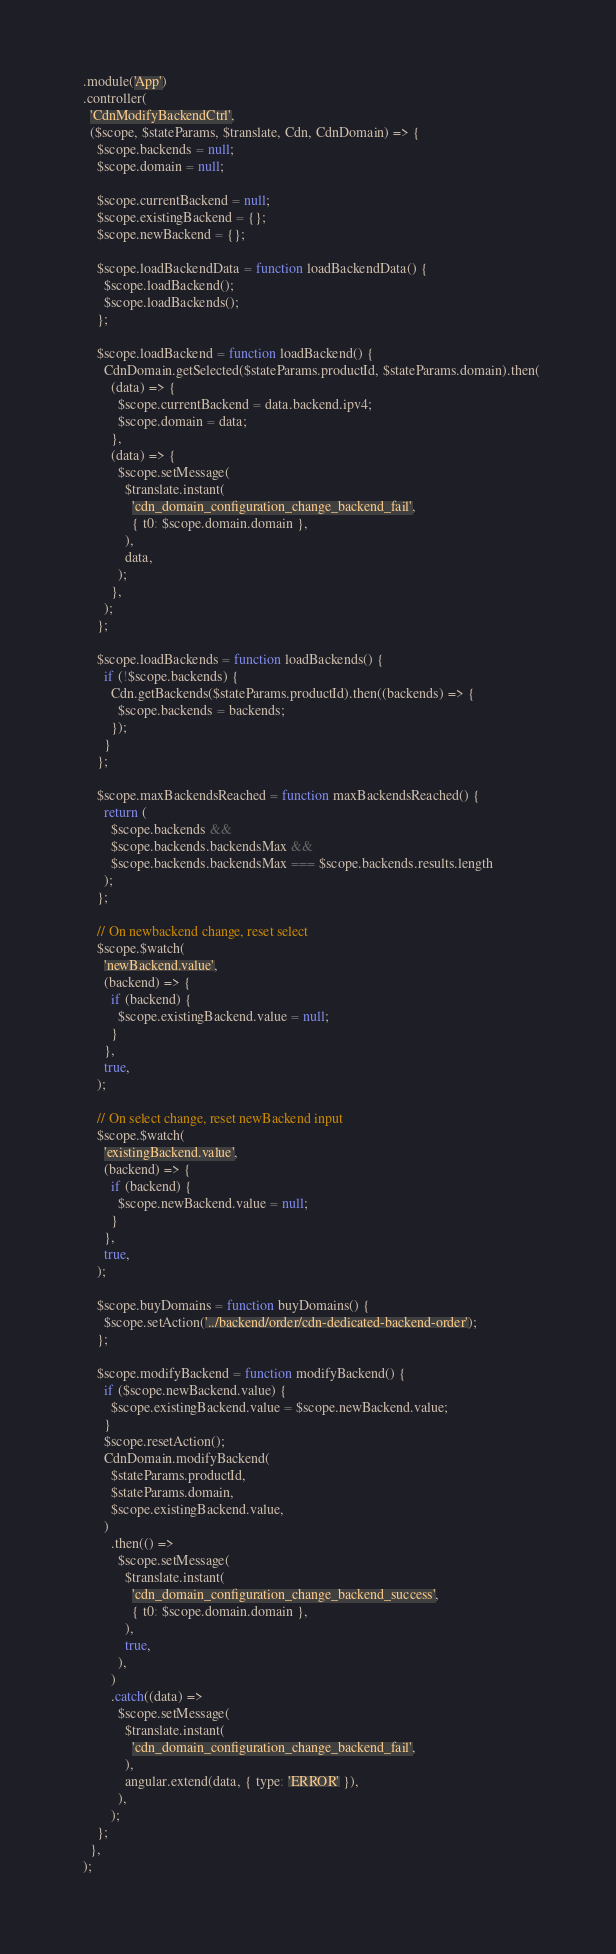<code> <loc_0><loc_0><loc_500><loc_500><_JavaScript_>  .module('App')
  .controller(
    'CdnModifyBackendCtrl',
    ($scope, $stateParams, $translate, Cdn, CdnDomain) => {
      $scope.backends = null;
      $scope.domain = null;

      $scope.currentBackend = null;
      $scope.existingBackend = {};
      $scope.newBackend = {};

      $scope.loadBackendData = function loadBackendData() {
        $scope.loadBackend();
        $scope.loadBackends();
      };

      $scope.loadBackend = function loadBackend() {
        CdnDomain.getSelected($stateParams.productId, $stateParams.domain).then(
          (data) => {
            $scope.currentBackend = data.backend.ipv4;
            $scope.domain = data;
          },
          (data) => {
            $scope.setMessage(
              $translate.instant(
                'cdn_domain_configuration_change_backend_fail',
                { t0: $scope.domain.domain },
              ),
              data,
            );
          },
        );
      };

      $scope.loadBackends = function loadBackends() {
        if (!$scope.backends) {
          Cdn.getBackends($stateParams.productId).then((backends) => {
            $scope.backends = backends;
          });
        }
      };

      $scope.maxBackendsReached = function maxBackendsReached() {
        return (
          $scope.backends &&
          $scope.backends.backendsMax &&
          $scope.backends.backendsMax === $scope.backends.results.length
        );
      };

      // On newbackend change, reset select
      $scope.$watch(
        'newBackend.value',
        (backend) => {
          if (backend) {
            $scope.existingBackend.value = null;
          }
        },
        true,
      );

      // On select change, reset newBackend input
      $scope.$watch(
        'existingBackend.value',
        (backend) => {
          if (backend) {
            $scope.newBackend.value = null;
          }
        },
        true,
      );

      $scope.buyDomains = function buyDomains() {
        $scope.setAction('../backend/order/cdn-dedicated-backend-order');
      };

      $scope.modifyBackend = function modifyBackend() {
        if ($scope.newBackend.value) {
          $scope.existingBackend.value = $scope.newBackend.value;
        }
        $scope.resetAction();
        CdnDomain.modifyBackend(
          $stateParams.productId,
          $stateParams.domain,
          $scope.existingBackend.value,
        )
          .then(() =>
            $scope.setMessage(
              $translate.instant(
                'cdn_domain_configuration_change_backend_success',
                { t0: $scope.domain.domain },
              ),
              true,
            ),
          )
          .catch((data) =>
            $scope.setMessage(
              $translate.instant(
                'cdn_domain_configuration_change_backend_fail',
              ),
              angular.extend(data, { type: 'ERROR' }),
            ),
          );
      };
    },
  );
</code> 